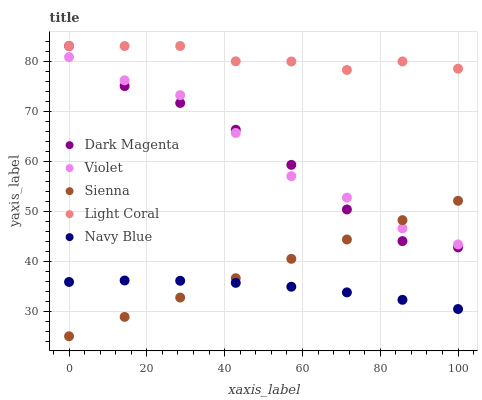Does Navy Blue have the minimum area under the curve?
Answer yes or no. Yes. Does Light Coral have the maximum area under the curve?
Answer yes or no. Yes. Does Light Coral have the minimum area under the curve?
Answer yes or no. No. Does Navy Blue have the maximum area under the curve?
Answer yes or no. No. Is Sienna the smoothest?
Answer yes or no. Yes. Is Dark Magenta the roughest?
Answer yes or no. Yes. Is Light Coral the smoothest?
Answer yes or no. No. Is Light Coral the roughest?
Answer yes or no. No. Does Sienna have the lowest value?
Answer yes or no. Yes. Does Navy Blue have the lowest value?
Answer yes or no. No. Does Dark Magenta have the highest value?
Answer yes or no. Yes. Does Navy Blue have the highest value?
Answer yes or no. No. Is Sienna less than Light Coral?
Answer yes or no. Yes. Is Dark Magenta greater than Navy Blue?
Answer yes or no. Yes. Does Dark Magenta intersect Violet?
Answer yes or no. Yes. Is Dark Magenta less than Violet?
Answer yes or no. No. Is Dark Magenta greater than Violet?
Answer yes or no. No. Does Sienna intersect Light Coral?
Answer yes or no. No. 